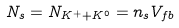Convert formula to latex. <formula><loc_0><loc_0><loc_500><loc_500>N _ { s } = N _ { K ^ { + } + K ^ { 0 } } = n _ { s } V _ { f b }</formula> 